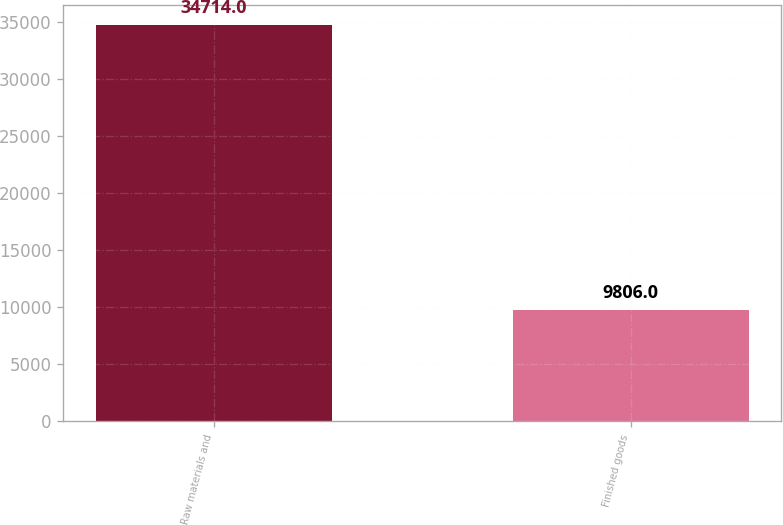Convert chart. <chart><loc_0><loc_0><loc_500><loc_500><bar_chart><fcel>Raw materials and<fcel>Finished goods<nl><fcel>34714<fcel>9806<nl></chart> 